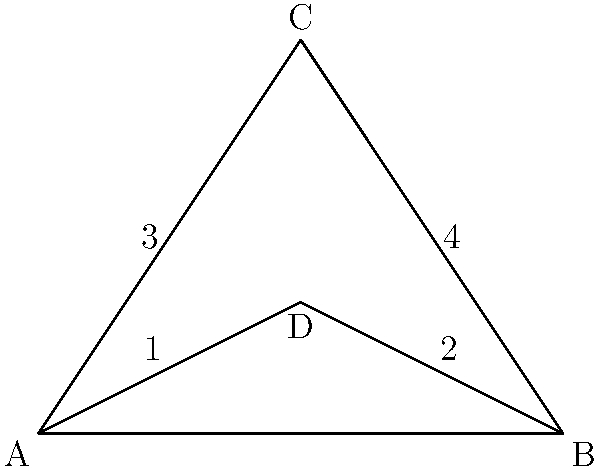In the diagram of a radiation therapy machine's beam collimator, triangles are used to represent the adjustable blades. Which pairs of triangles are congruent? To determine which triangles are congruent, we need to examine the properties of the triangles in the diagram:

1. Triangle ADB is a right triangle with the right angle at D.
2. Triangle ADC and triangle BDC share the same height (the distance from C to AB).
3. AD = DB because D is the midpoint of AB (as it's the point where the perpendicular from C meets AB in an isosceles triangle).

Now, let's analyze the triangles:

1. Triangle ADB is divided into two smaller triangles by the perpendicular from C.
2. Triangle ADC and triangle BDC are both isosceles triangles because:
   - They share the same height
   - AD = DB (as established earlier)
   - AC = BC (because ABC is an isosceles triangle)

Therefore, we can conclude that:

- Triangle 1 (ACD) is congruent to Triangle 2 (BCD) because:
  * They share a common side (CD)
  * AC = BC
  * AD = DB

- Triangle 3 (ACD) is congruent to Triangle 4 (BCD) for the same reasons as above.

The congruence of these triangles is crucial in radiation therapy as it ensures that the beam collimator blades are symmetrically positioned, allowing for precise and even distribution of radiation to the target area.
Answer: Triangles 1 and 2; Triangles 3 and 4 